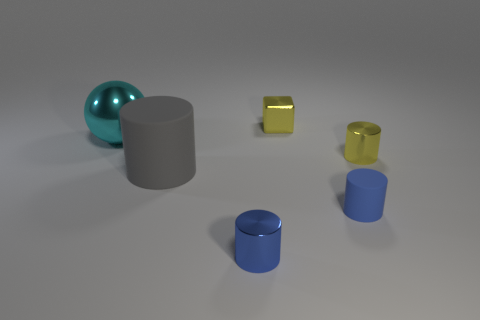There is a tiny yellow metallic object in front of the big ball; is it the same shape as the blue metallic thing?
Your answer should be compact. Yes. Are there any other things that have the same shape as the large shiny thing?
Your answer should be very brief. No. What number of cubes are either small objects or yellow metal objects?
Provide a succinct answer. 1. How many big red cylinders are there?
Keep it short and to the point. 0. There is a metal cylinder right of the yellow object that is behind the big cyan metal ball; what size is it?
Offer a terse response. Small. How many other things are the same size as the block?
Offer a very short reply. 3. There is a cyan thing; what number of cyan shiny objects are to the left of it?
Provide a short and direct response. 0. What size is the cyan metal ball?
Offer a very short reply. Large. Is the material of the yellow thing that is in front of the metal ball the same as the object that is behind the ball?
Offer a terse response. Yes. Is there a object of the same color as the tiny matte cylinder?
Your answer should be very brief. Yes. 